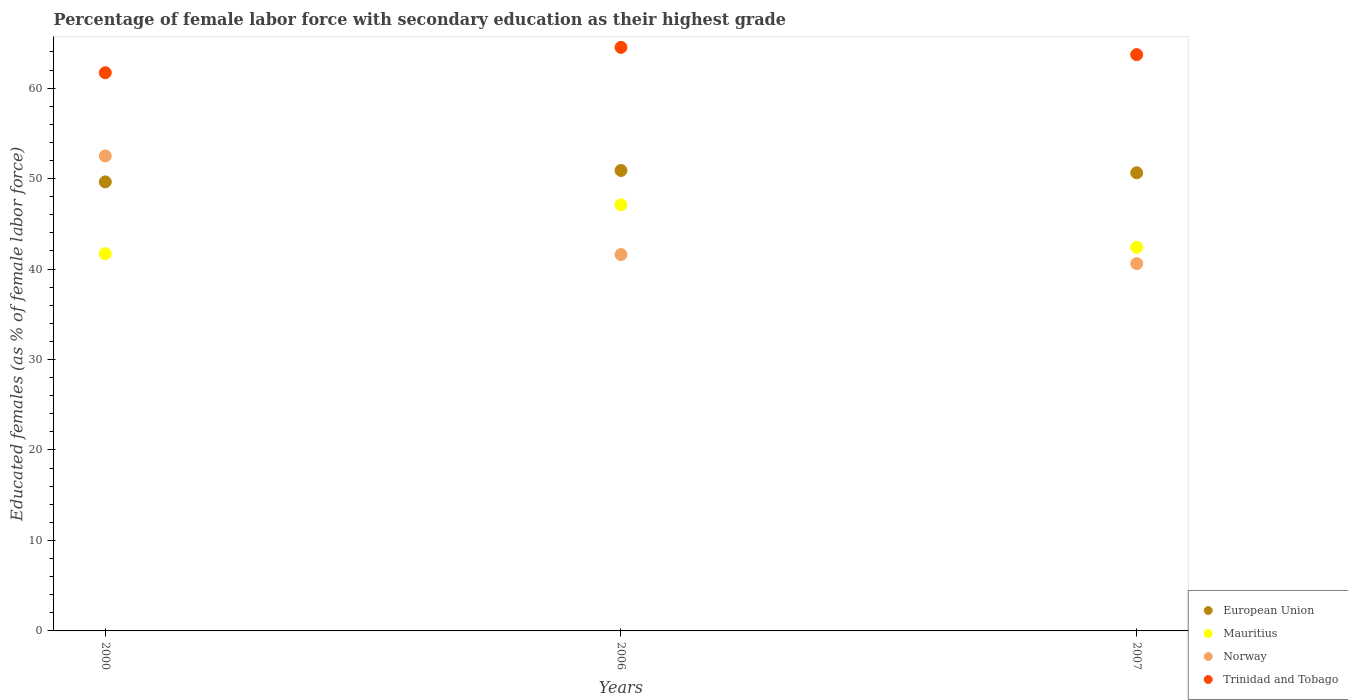Is the number of dotlines equal to the number of legend labels?
Make the answer very short. Yes. What is the percentage of female labor force with secondary education in Mauritius in 2007?
Offer a terse response. 42.4. Across all years, what is the maximum percentage of female labor force with secondary education in European Union?
Ensure brevity in your answer.  50.9. Across all years, what is the minimum percentage of female labor force with secondary education in Mauritius?
Provide a succinct answer. 41.7. What is the total percentage of female labor force with secondary education in Trinidad and Tobago in the graph?
Your answer should be very brief. 189.9. What is the difference between the percentage of female labor force with secondary education in Trinidad and Tobago in 2000 and that in 2006?
Your answer should be compact. -2.8. What is the difference between the percentage of female labor force with secondary education in Mauritius in 2006 and the percentage of female labor force with secondary education in Trinidad and Tobago in 2000?
Your response must be concise. -14.6. What is the average percentage of female labor force with secondary education in Trinidad and Tobago per year?
Offer a terse response. 63.3. In the year 2000, what is the difference between the percentage of female labor force with secondary education in Norway and percentage of female labor force with secondary education in Trinidad and Tobago?
Ensure brevity in your answer.  -9.2. In how many years, is the percentage of female labor force with secondary education in Norway greater than 44 %?
Your answer should be very brief. 1. What is the ratio of the percentage of female labor force with secondary education in Norway in 2000 to that in 2007?
Ensure brevity in your answer.  1.29. What is the difference between the highest and the second highest percentage of female labor force with secondary education in Trinidad and Tobago?
Ensure brevity in your answer.  0.8. What is the difference between the highest and the lowest percentage of female labor force with secondary education in Norway?
Offer a very short reply. 11.9. Is it the case that in every year, the sum of the percentage of female labor force with secondary education in Mauritius and percentage of female labor force with secondary education in Trinidad and Tobago  is greater than the percentage of female labor force with secondary education in Norway?
Provide a succinct answer. Yes. How many years are there in the graph?
Your answer should be very brief. 3. Are the values on the major ticks of Y-axis written in scientific E-notation?
Make the answer very short. No. Does the graph contain any zero values?
Provide a short and direct response. No. Does the graph contain grids?
Give a very brief answer. No. Where does the legend appear in the graph?
Give a very brief answer. Bottom right. How many legend labels are there?
Your answer should be compact. 4. What is the title of the graph?
Your response must be concise. Percentage of female labor force with secondary education as their highest grade. What is the label or title of the Y-axis?
Your answer should be compact. Educated females (as % of female labor force). What is the Educated females (as % of female labor force) of European Union in 2000?
Provide a succinct answer. 49.63. What is the Educated females (as % of female labor force) of Mauritius in 2000?
Your response must be concise. 41.7. What is the Educated females (as % of female labor force) of Norway in 2000?
Your response must be concise. 52.5. What is the Educated females (as % of female labor force) in Trinidad and Tobago in 2000?
Provide a succinct answer. 61.7. What is the Educated females (as % of female labor force) of European Union in 2006?
Provide a succinct answer. 50.9. What is the Educated females (as % of female labor force) in Mauritius in 2006?
Keep it short and to the point. 47.1. What is the Educated females (as % of female labor force) in Norway in 2006?
Offer a very short reply. 41.6. What is the Educated females (as % of female labor force) of Trinidad and Tobago in 2006?
Provide a succinct answer. 64.5. What is the Educated females (as % of female labor force) of European Union in 2007?
Provide a succinct answer. 50.64. What is the Educated females (as % of female labor force) in Mauritius in 2007?
Make the answer very short. 42.4. What is the Educated females (as % of female labor force) of Norway in 2007?
Make the answer very short. 40.6. What is the Educated females (as % of female labor force) of Trinidad and Tobago in 2007?
Your answer should be very brief. 63.7. Across all years, what is the maximum Educated females (as % of female labor force) of European Union?
Give a very brief answer. 50.9. Across all years, what is the maximum Educated females (as % of female labor force) of Mauritius?
Give a very brief answer. 47.1. Across all years, what is the maximum Educated females (as % of female labor force) in Norway?
Your answer should be very brief. 52.5. Across all years, what is the maximum Educated females (as % of female labor force) in Trinidad and Tobago?
Provide a short and direct response. 64.5. Across all years, what is the minimum Educated females (as % of female labor force) in European Union?
Make the answer very short. 49.63. Across all years, what is the minimum Educated females (as % of female labor force) in Mauritius?
Keep it short and to the point. 41.7. Across all years, what is the minimum Educated females (as % of female labor force) in Norway?
Offer a terse response. 40.6. Across all years, what is the minimum Educated females (as % of female labor force) in Trinidad and Tobago?
Provide a succinct answer. 61.7. What is the total Educated females (as % of female labor force) of European Union in the graph?
Your answer should be very brief. 151.17. What is the total Educated females (as % of female labor force) in Mauritius in the graph?
Your response must be concise. 131.2. What is the total Educated females (as % of female labor force) in Norway in the graph?
Your answer should be compact. 134.7. What is the total Educated females (as % of female labor force) of Trinidad and Tobago in the graph?
Ensure brevity in your answer.  189.9. What is the difference between the Educated females (as % of female labor force) in European Union in 2000 and that in 2006?
Provide a short and direct response. -1.26. What is the difference between the Educated females (as % of female labor force) in European Union in 2000 and that in 2007?
Your response must be concise. -1.01. What is the difference between the Educated females (as % of female labor force) in Mauritius in 2000 and that in 2007?
Offer a terse response. -0.7. What is the difference between the Educated females (as % of female labor force) in Norway in 2000 and that in 2007?
Keep it short and to the point. 11.9. What is the difference between the Educated females (as % of female labor force) of European Union in 2006 and that in 2007?
Provide a short and direct response. 0.26. What is the difference between the Educated females (as % of female labor force) of Trinidad and Tobago in 2006 and that in 2007?
Offer a very short reply. 0.8. What is the difference between the Educated females (as % of female labor force) of European Union in 2000 and the Educated females (as % of female labor force) of Mauritius in 2006?
Keep it short and to the point. 2.53. What is the difference between the Educated females (as % of female labor force) in European Union in 2000 and the Educated females (as % of female labor force) in Norway in 2006?
Your answer should be very brief. 8.03. What is the difference between the Educated females (as % of female labor force) in European Union in 2000 and the Educated females (as % of female labor force) in Trinidad and Tobago in 2006?
Offer a terse response. -14.87. What is the difference between the Educated females (as % of female labor force) of Mauritius in 2000 and the Educated females (as % of female labor force) of Trinidad and Tobago in 2006?
Ensure brevity in your answer.  -22.8. What is the difference between the Educated females (as % of female labor force) of European Union in 2000 and the Educated females (as % of female labor force) of Mauritius in 2007?
Offer a very short reply. 7.23. What is the difference between the Educated females (as % of female labor force) of European Union in 2000 and the Educated females (as % of female labor force) of Norway in 2007?
Your response must be concise. 9.03. What is the difference between the Educated females (as % of female labor force) of European Union in 2000 and the Educated females (as % of female labor force) of Trinidad and Tobago in 2007?
Make the answer very short. -14.07. What is the difference between the Educated females (as % of female labor force) in Mauritius in 2000 and the Educated females (as % of female labor force) in Norway in 2007?
Your response must be concise. 1.1. What is the difference between the Educated females (as % of female labor force) of Mauritius in 2000 and the Educated females (as % of female labor force) of Trinidad and Tobago in 2007?
Provide a succinct answer. -22. What is the difference between the Educated females (as % of female labor force) in European Union in 2006 and the Educated females (as % of female labor force) in Mauritius in 2007?
Provide a short and direct response. 8.5. What is the difference between the Educated females (as % of female labor force) in European Union in 2006 and the Educated females (as % of female labor force) in Norway in 2007?
Give a very brief answer. 10.3. What is the difference between the Educated females (as % of female labor force) in European Union in 2006 and the Educated females (as % of female labor force) in Trinidad and Tobago in 2007?
Your answer should be compact. -12.8. What is the difference between the Educated females (as % of female labor force) in Mauritius in 2006 and the Educated females (as % of female labor force) in Norway in 2007?
Your response must be concise. 6.5. What is the difference between the Educated females (as % of female labor force) in Mauritius in 2006 and the Educated females (as % of female labor force) in Trinidad and Tobago in 2007?
Provide a succinct answer. -16.6. What is the difference between the Educated females (as % of female labor force) of Norway in 2006 and the Educated females (as % of female labor force) of Trinidad and Tobago in 2007?
Give a very brief answer. -22.1. What is the average Educated females (as % of female labor force) of European Union per year?
Provide a short and direct response. 50.39. What is the average Educated females (as % of female labor force) of Mauritius per year?
Your response must be concise. 43.73. What is the average Educated females (as % of female labor force) of Norway per year?
Provide a short and direct response. 44.9. What is the average Educated females (as % of female labor force) in Trinidad and Tobago per year?
Offer a very short reply. 63.3. In the year 2000, what is the difference between the Educated females (as % of female labor force) of European Union and Educated females (as % of female labor force) of Mauritius?
Your response must be concise. 7.93. In the year 2000, what is the difference between the Educated females (as % of female labor force) of European Union and Educated females (as % of female labor force) of Norway?
Keep it short and to the point. -2.87. In the year 2000, what is the difference between the Educated females (as % of female labor force) of European Union and Educated females (as % of female labor force) of Trinidad and Tobago?
Ensure brevity in your answer.  -12.07. In the year 2000, what is the difference between the Educated females (as % of female labor force) of Mauritius and Educated females (as % of female labor force) of Norway?
Your response must be concise. -10.8. In the year 2006, what is the difference between the Educated females (as % of female labor force) of European Union and Educated females (as % of female labor force) of Mauritius?
Keep it short and to the point. 3.8. In the year 2006, what is the difference between the Educated females (as % of female labor force) in European Union and Educated females (as % of female labor force) in Norway?
Your response must be concise. 9.3. In the year 2006, what is the difference between the Educated females (as % of female labor force) of European Union and Educated females (as % of female labor force) of Trinidad and Tobago?
Keep it short and to the point. -13.6. In the year 2006, what is the difference between the Educated females (as % of female labor force) of Mauritius and Educated females (as % of female labor force) of Trinidad and Tobago?
Make the answer very short. -17.4. In the year 2006, what is the difference between the Educated females (as % of female labor force) in Norway and Educated females (as % of female labor force) in Trinidad and Tobago?
Your answer should be very brief. -22.9. In the year 2007, what is the difference between the Educated females (as % of female labor force) in European Union and Educated females (as % of female labor force) in Mauritius?
Keep it short and to the point. 8.24. In the year 2007, what is the difference between the Educated females (as % of female labor force) in European Union and Educated females (as % of female labor force) in Norway?
Give a very brief answer. 10.04. In the year 2007, what is the difference between the Educated females (as % of female labor force) of European Union and Educated females (as % of female labor force) of Trinidad and Tobago?
Keep it short and to the point. -13.06. In the year 2007, what is the difference between the Educated females (as % of female labor force) of Mauritius and Educated females (as % of female labor force) of Norway?
Your answer should be compact. 1.8. In the year 2007, what is the difference between the Educated females (as % of female labor force) of Mauritius and Educated females (as % of female labor force) of Trinidad and Tobago?
Provide a short and direct response. -21.3. In the year 2007, what is the difference between the Educated females (as % of female labor force) in Norway and Educated females (as % of female labor force) in Trinidad and Tobago?
Keep it short and to the point. -23.1. What is the ratio of the Educated females (as % of female labor force) in European Union in 2000 to that in 2006?
Your response must be concise. 0.98. What is the ratio of the Educated females (as % of female labor force) of Mauritius in 2000 to that in 2006?
Offer a terse response. 0.89. What is the ratio of the Educated females (as % of female labor force) of Norway in 2000 to that in 2006?
Make the answer very short. 1.26. What is the ratio of the Educated females (as % of female labor force) of Trinidad and Tobago in 2000 to that in 2006?
Provide a succinct answer. 0.96. What is the ratio of the Educated females (as % of female labor force) of European Union in 2000 to that in 2007?
Your response must be concise. 0.98. What is the ratio of the Educated females (as % of female labor force) of Mauritius in 2000 to that in 2007?
Provide a succinct answer. 0.98. What is the ratio of the Educated females (as % of female labor force) in Norway in 2000 to that in 2007?
Provide a succinct answer. 1.29. What is the ratio of the Educated females (as % of female labor force) in Trinidad and Tobago in 2000 to that in 2007?
Ensure brevity in your answer.  0.97. What is the ratio of the Educated females (as % of female labor force) in European Union in 2006 to that in 2007?
Make the answer very short. 1.01. What is the ratio of the Educated females (as % of female labor force) in Mauritius in 2006 to that in 2007?
Keep it short and to the point. 1.11. What is the ratio of the Educated females (as % of female labor force) of Norway in 2006 to that in 2007?
Make the answer very short. 1.02. What is the ratio of the Educated females (as % of female labor force) in Trinidad and Tobago in 2006 to that in 2007?
Provide a succinct answer. 1.01. What is the difference between the highest and the second highest Educated females (as % of female labor force) of European Union?
Offer a very short reply. 0.26. What is the difference between the highest and the second highest Educated females (as % of female labor force) in Trinidad and Tobago?
Give a very brief answer. 0.8. What is the difference between the highest and the lowest Educated females (as % of female labor force) in European Union?
Ensure brevity in your answer.  1.26. What is the difference between the highest and the lowest Educated females (as % of female labor force) of Norway?
Make the answer very short. 11.9. What is the difference between the highest and the lowest Educated females (as % of female labor force) of Trinidad and Tobago?
Offer a terse response. 2.8. 